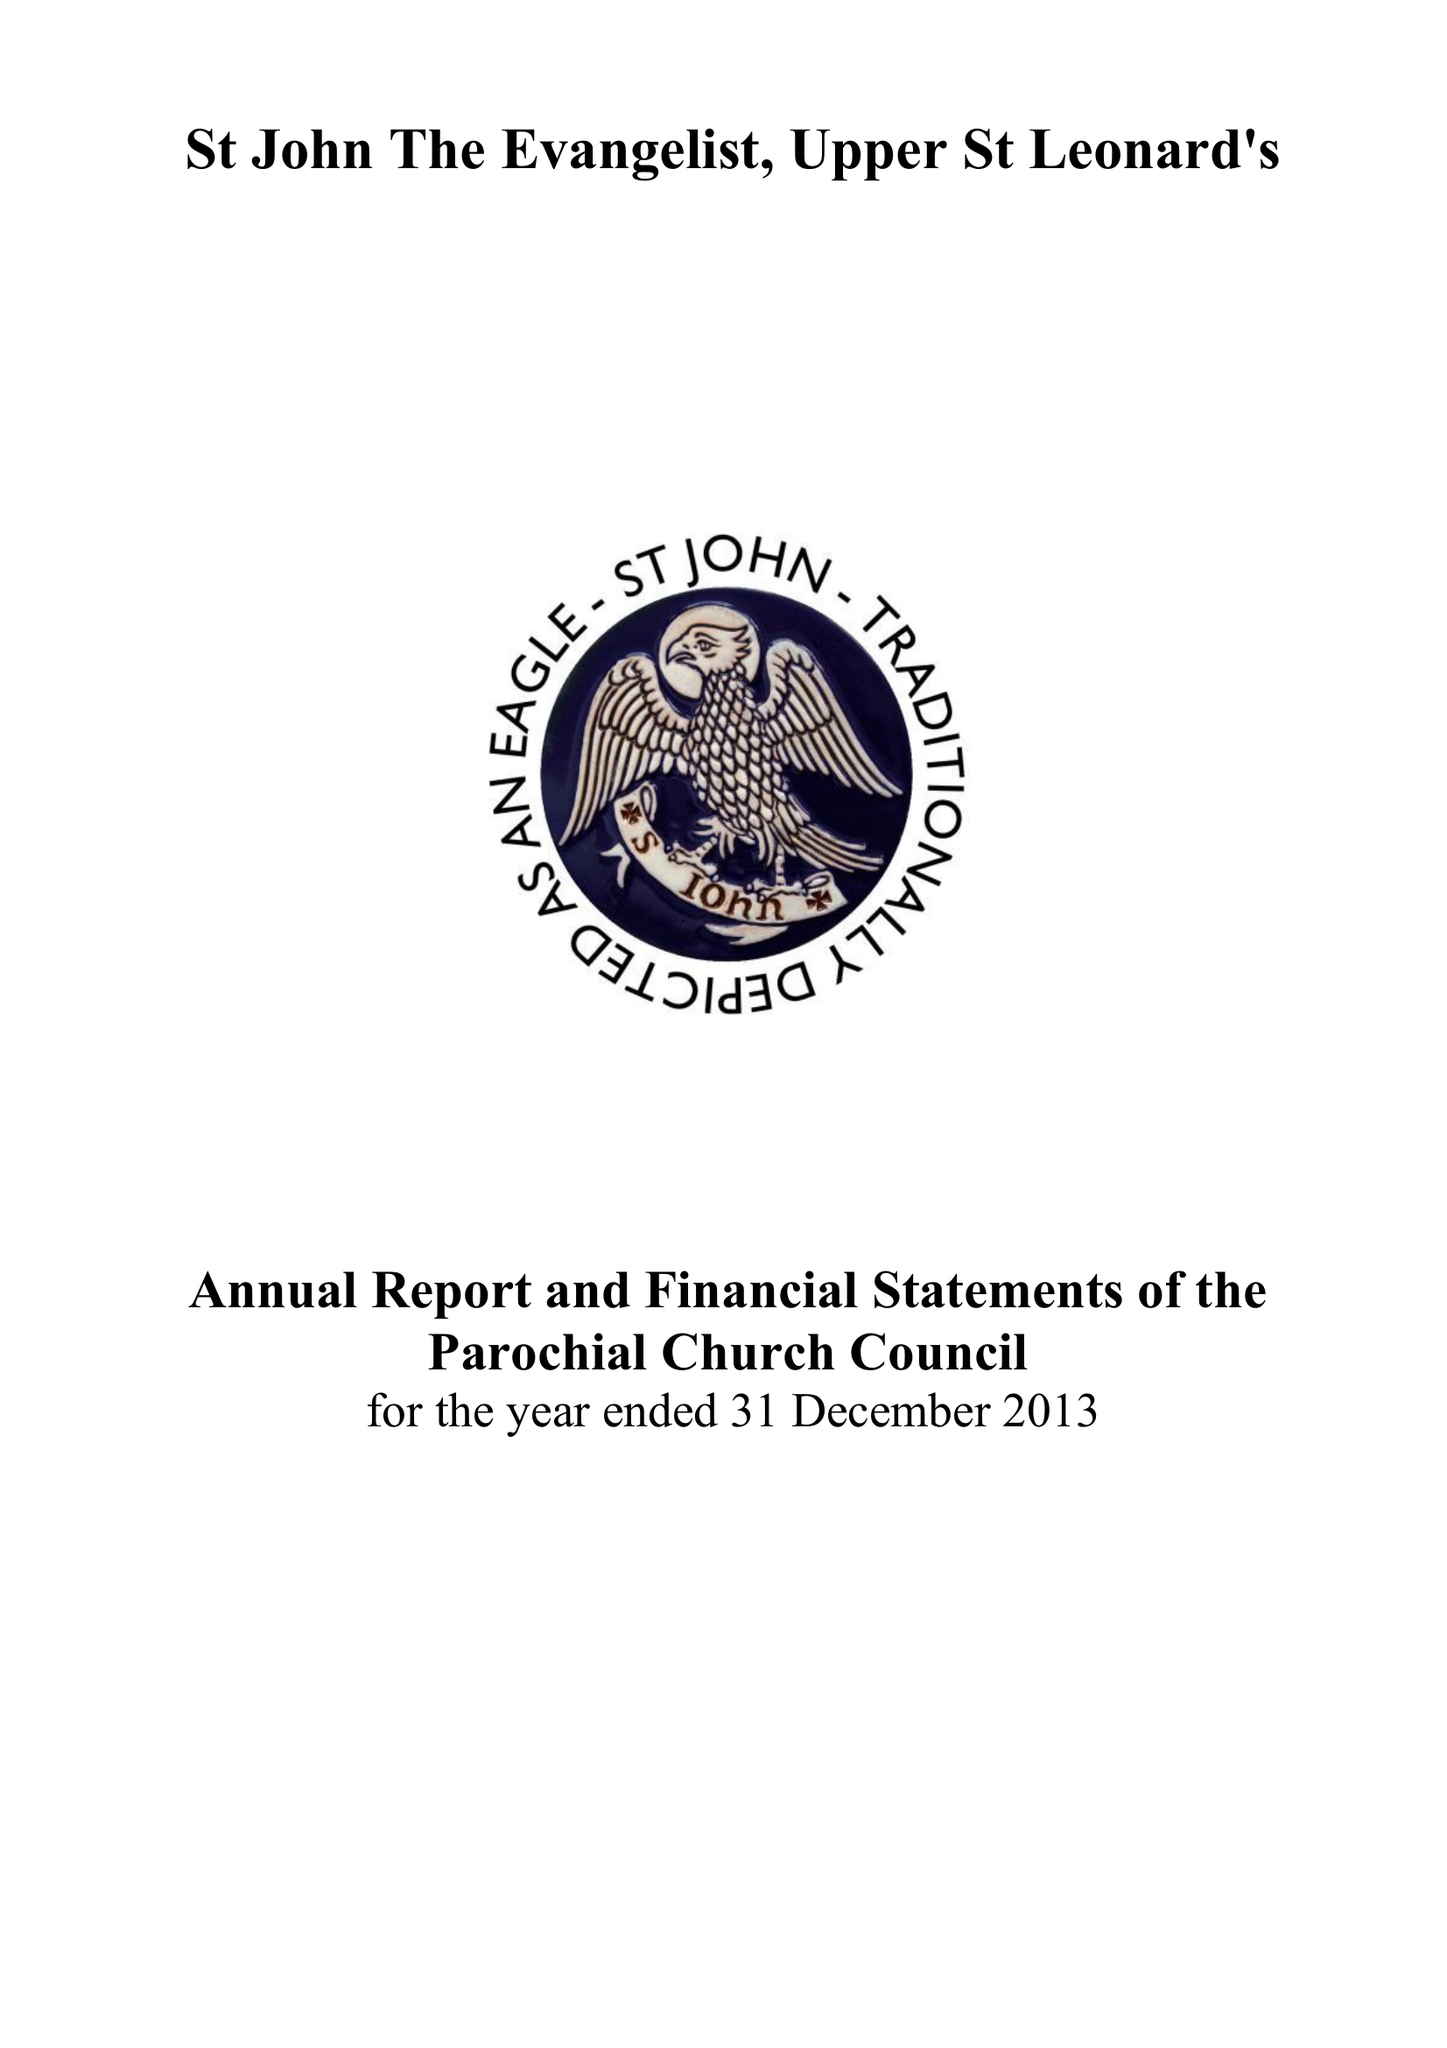What is the value for the charity_name?
Answer the question using a single word or phrase. The Parochial Church Council Of The Ecclesiastical Parish Of St John The Evangelist Upper St Leonards On Sea 